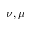<formula> <loc_0><loc_0><loc_500><loc_500>\nu , \mu</formula> 